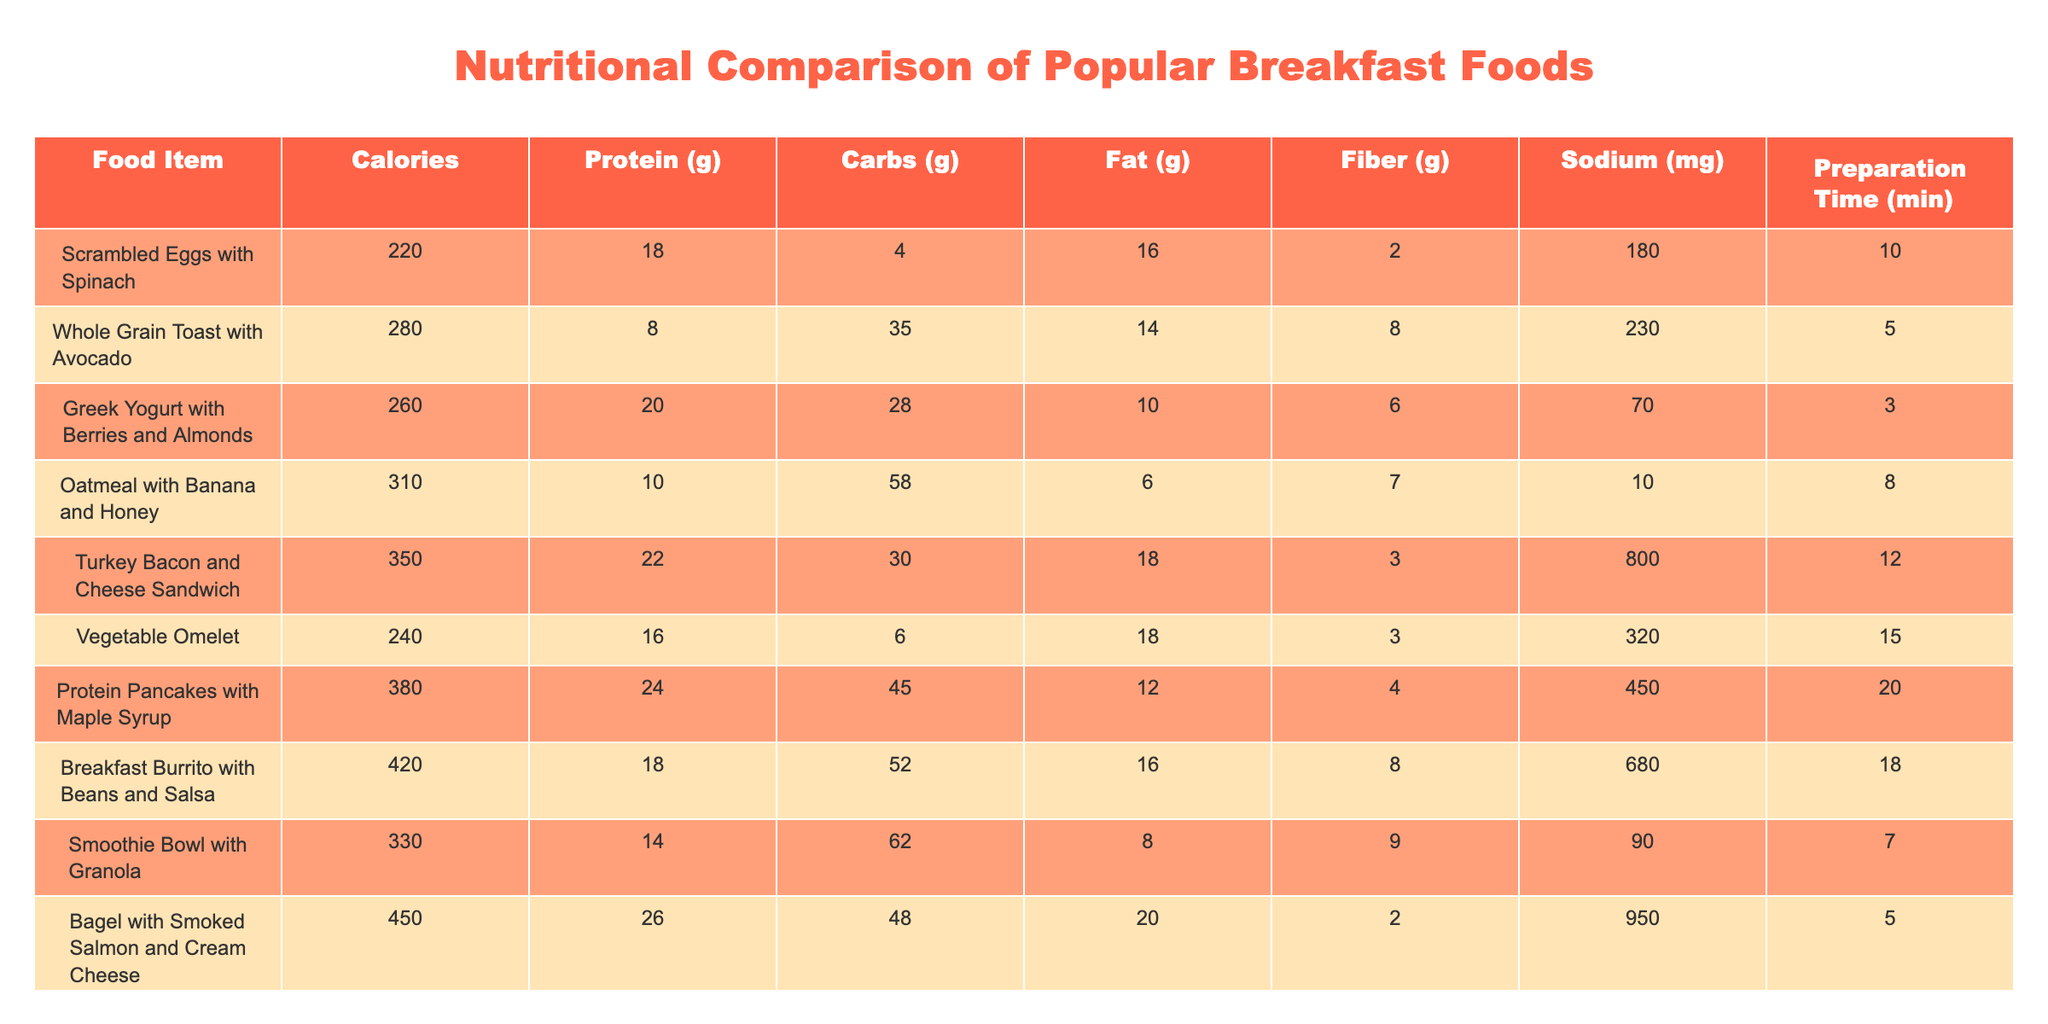What food item has the highest calorie content? By reviewing the "Calories" column, we see that the "Bagel with Smoked Salmon and Cream Cheese" has the highest value of 450 calories compared to other food items.
Answer: 450 Which breakfast item contains the most protein? Looking at the "Protein (g)" column, the "Bagel with Smoked Salmon and Cream Cheese" has the highest protein content at 26 grams.
Answer: 26 What is the total carbohydrate content of "Oatmeal with Banana and Honey" and "Whole Grain Toast with Avocado"? The carbohydrate content for "Oatmeal with Banana and Honey" is 58 grams, and for "Whole Grain Toast with Avocado," it is 35 grams. Summing these gives 58 + 35 = 93 grams.
Answer: 93 Does "Scrambled Eggs with Spinach" have more fiber than "Turkey Bacon and Cheese Sandwich"? "Scrambled Eggs with Spinach" contains 2 grams of fiber while "Turkey Bacon and Cheese Sandwich" contains 3 grams of fiber. Since 2 is less than 3, the answer is no.
Answer: No What is the average sodium content of the breakfast items listed? To find the average, sum up all the sodium values: 180 + 230 + 70 + 10 + 800 + 320 + 450 + 680 + 90 + 950 = 2850 mg. Then divide by the number of items, which is 10: 2850 / 10 = 285.
Answer: 285 Which item has the highest fat content, and what is that value? The "Turkey Bacon and Cheese Sandwich" has 18 grams of fat, which is higher than any other item listed in the "Fat (g)" column.
Answer: 18 If someone is looking for a quick breakfast option (under 10 minutes), which meal choices do they have? The items with a preparation time of 10 minutes or less are "Whole Grain Toast with Avocado" (5 min), "Greek Yogurt with Berries and Almonds" (3 min), and "Oatmeal with Banana and Honey" (8 min).
Answer: 3 choices What is the difference in calories between the "Protein Pancakes with Maple Syrup" and the "Breakfast Burrito with Beans and Salsa"? "Protein Pancakes with Maple Syrup" has 380 calories while "Breakfast Burrito with Beans and Salsa" has 420 calories. The difference is 420 - 380 = 40 calories.
Answer: 40 How many breakfast options contain more than 300 calories? By counting the items with calories greater than 300, we find these items: "Oatmeal with Banana and Honey" (310), "Turkey Bacon and Cheese Sandwich" (350), "Protein Pancakes with Maple Syrup" (380), "Breakfast Burrito with Beans and Salsa" (420), and "Bagel with Smoked Salmon and Cream Cheese" (450). This totals 5 options.
Answer: 5 Are there any items that have less than 10 grams of protein? Checking the "Protein (g)" column, the items "Whole Grain Toast with Avocado" (8 g) and "Oatmeal with Banana and Honey" (10 g) both have protein content below 10 grams, confirming that at least one item meets this criterion.
Answer: Yes 